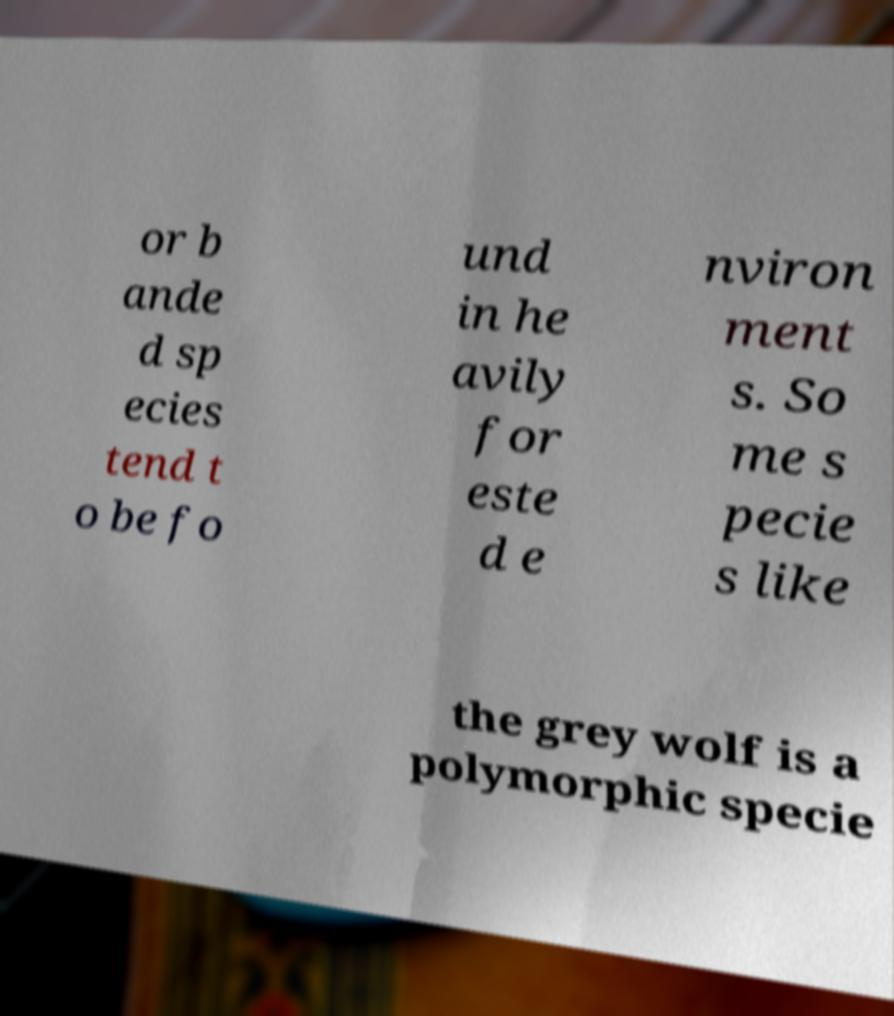Can you accurately transcribe the text from the provided image for me? or b ande d sp ecies tend t o be fo und in he avily for este d e nviron ment s. So me s pecie s like the grey wolf is a polymorphic specie 